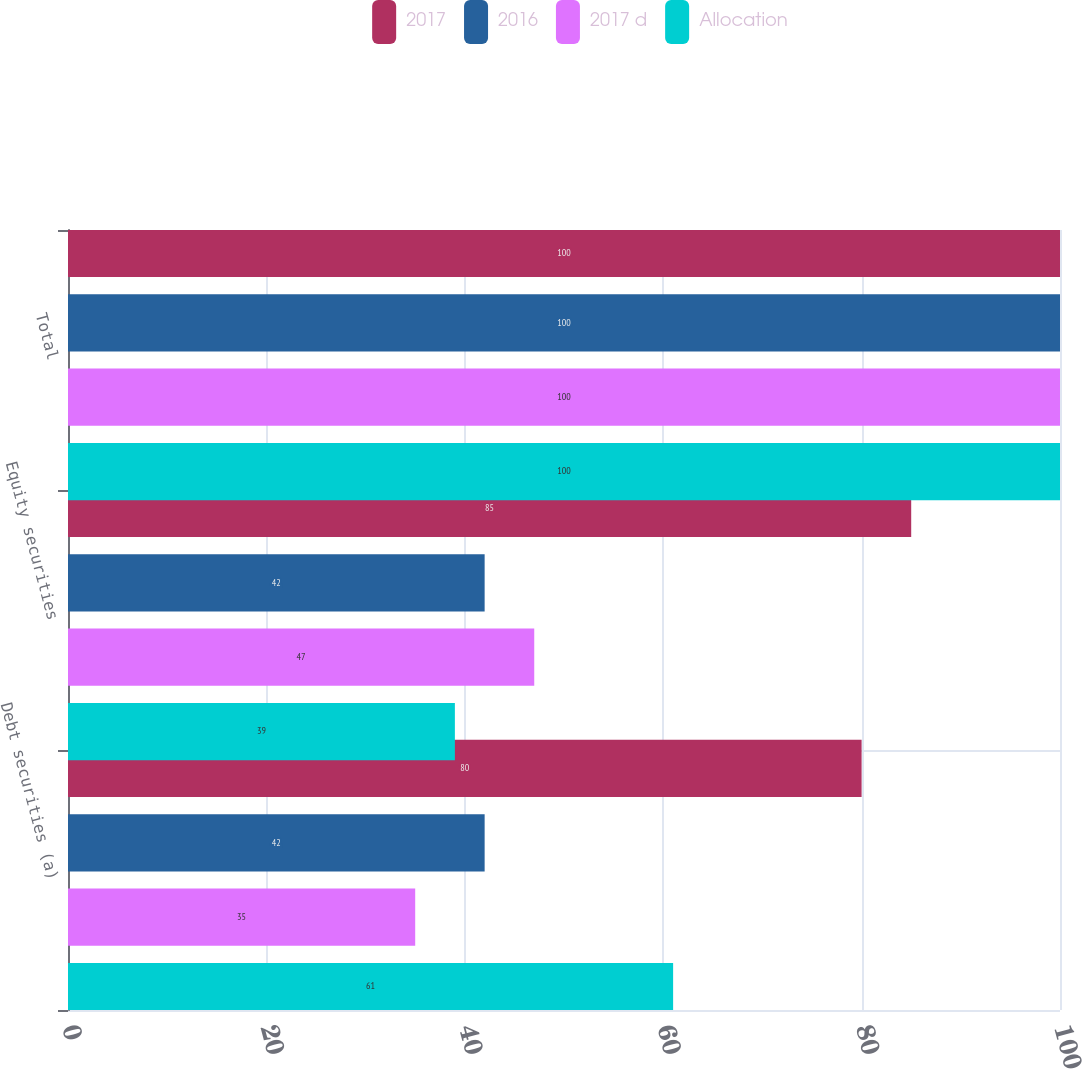Convert chart to OTSL. <chart><loc_0><loc_0><loc_500><loc_500><stacked_bar_chart><ecel><fcel>Debt securities (a)<fcel>Equity securities<fcel>Total<nl><fcel>2017<fcel>80<fcel>85<fcel>100<nl><fcel>2016<fcel>42<fcel>42<fcel>100<nl><fcel>2017 d<fcel>35<fcel>47<fcel>100<nl><fcel>Allocation<fcel>61<fcel>39<fcel>100<nl></chart> 